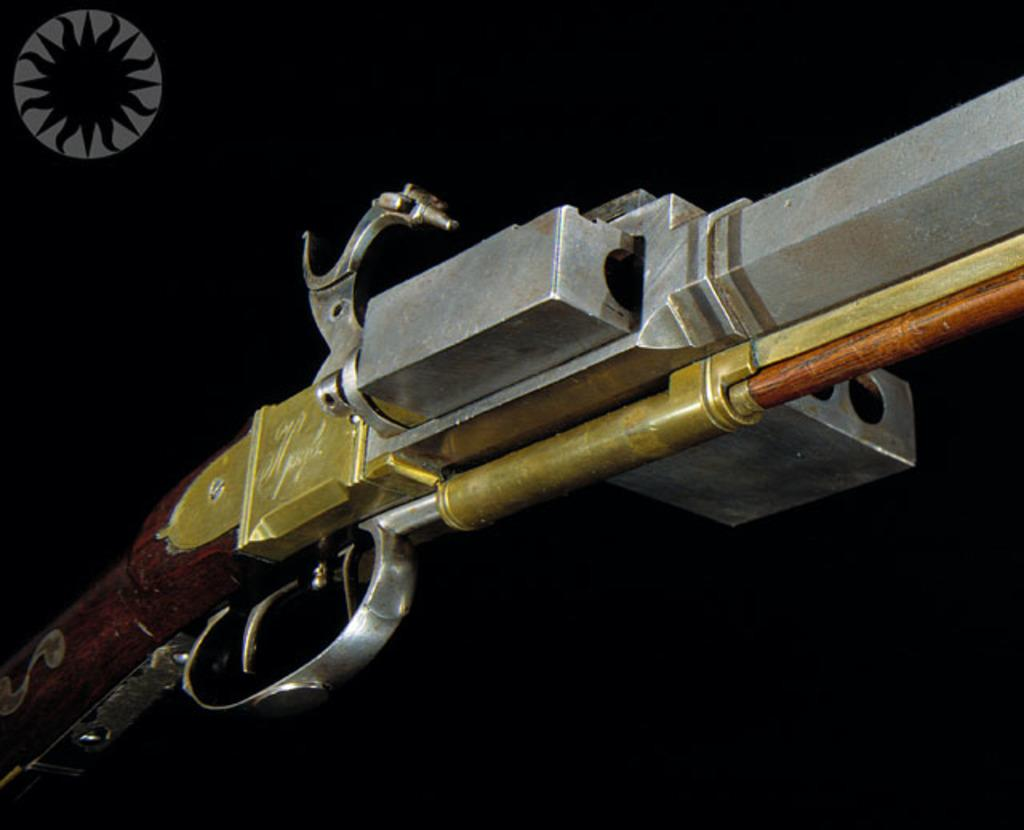What is the color of the background in the image? The background of the image is completely dark. What object can be seen in the picture? There is a rifle in the picture. What type of action is the wave performing in the image? There is no wave present in the image, and therefore no action can be observed. What is the rifle placed on in the image? The facts provided do not mention any tray or surface that the rifle might be placed on. 